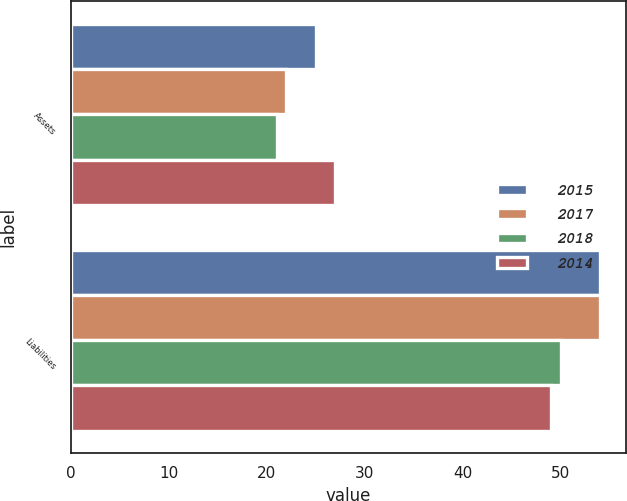Convert chart to OTSL. <chart><loc_0><loc_0><loc_500><loc_500><stacked_bar_chart><ecel><fcel>Assets<fcel>Liabilities<nl><fcel>2015<fcel>25<fcel>54<nl><fcel>2017<fcel>22<fcel>54<nl><fcel>2018<fcel>21<fcel>50<nl><fcel>2014<fcel>27<fcel>49<nl></chart> 